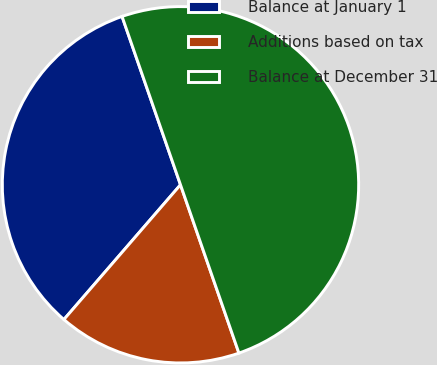Convert chart. <chart><loc_0><loc_0><loc_500><loc_500><pie_chart><fcel>Balance at January 1<fcel>Additions based on tax<fcel>Balance at December 31<nl><fcel>33.33%<fcel>16.67%<fcel>50.0%<nl></chart> 